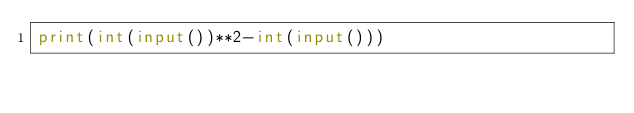<code> <loc_0><loc_0><loc_500><loc_500><_Python_>print(int(input())**2-int(input()))</code> 